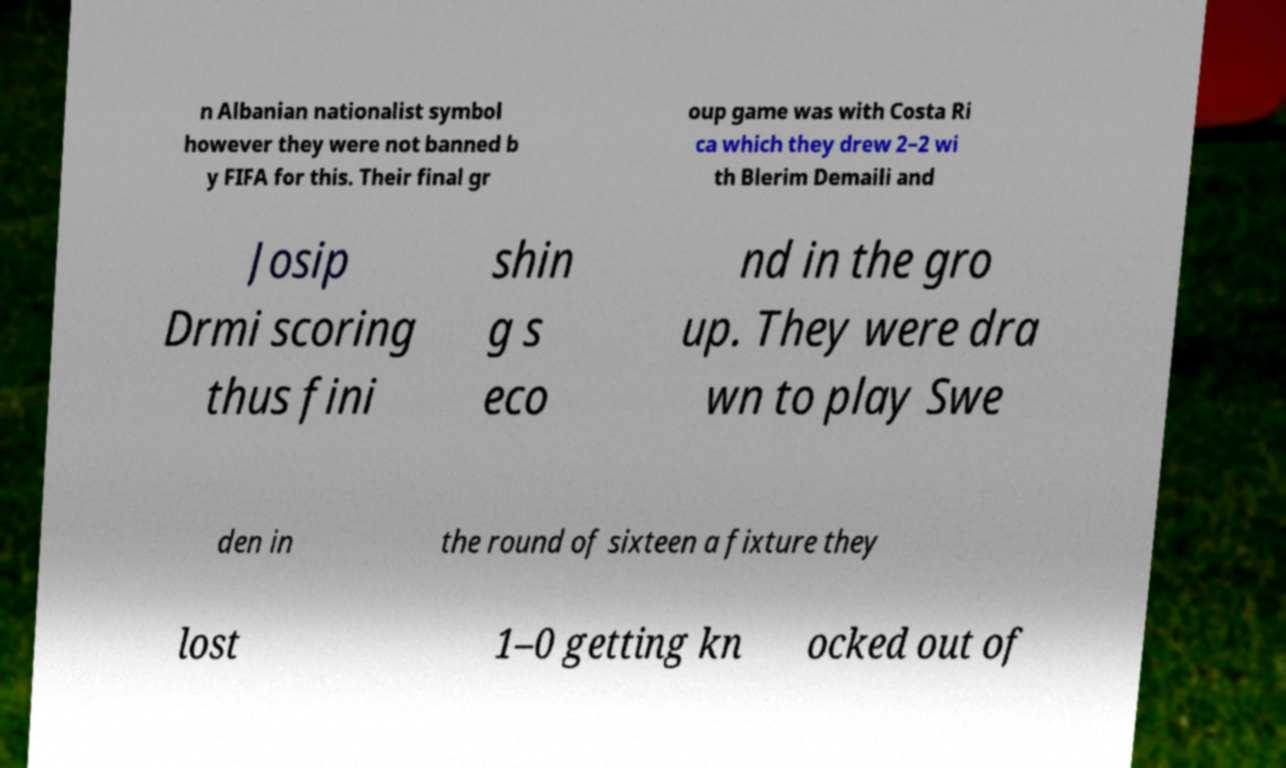There's text embedded in this image that I need extracted. Can you transcribe it verbatim? n Albanian nationalist symbol however they were not banned b y FIFA for this. Their final gr oup game was with Costa Ri ca which they drew 2–2 wi th Blerim Demaili and Josip Drmi scoring thus fini shin g s eco nd in the gro up. They were dra wn to play Swe den in the round of sixteen a fixture they lost 1–0 getting kn ocked out of 